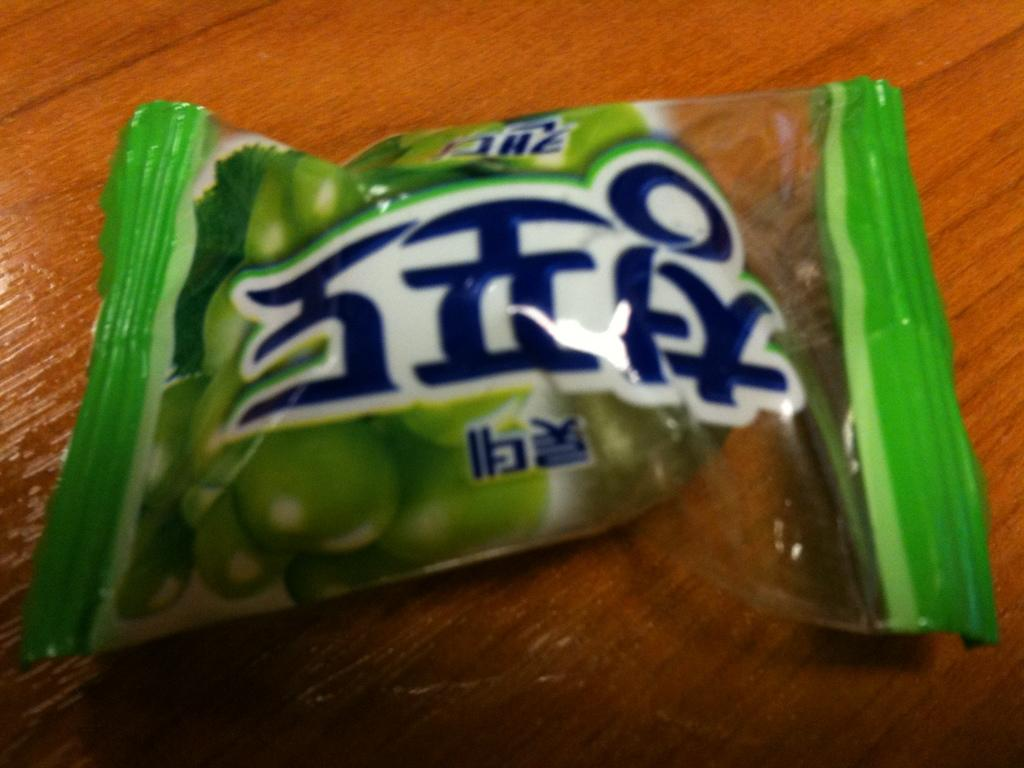<image>
Present a compact description of the photo's key features. A small package of green candy features an Asian language on the label. 